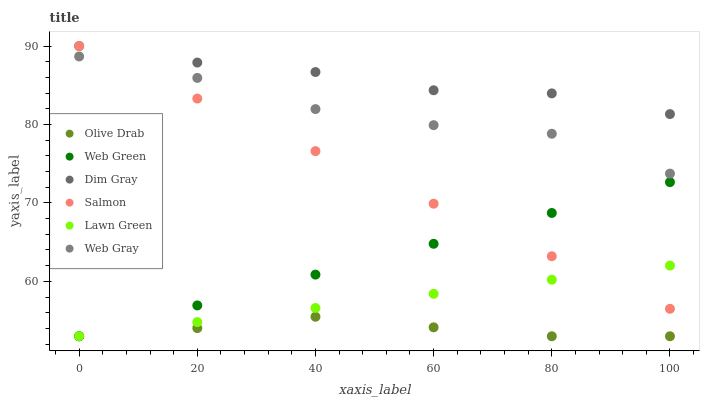Does Olive Drab have the minimum area under the curve?
Answer yes or no. Yes. Does Dim Gray have the maximum area under the curve?
Answer yes or no. Yes. Does Web Gray have the minimum area under the curve?
Answer yes or no. No. Does Web Gray have the maximum area under the curve?
Answer yes or no. No. Is Web Green the smoothest?
Answer yes or no. Yes. Is Web Gray the roughest?
Answer yes or no. Yes. Is Salmon the smoothest?
Answer yes or no. No. Is Salmon the roughest?
Answer yes or no. No. Does Lawn Green have the lowest value?
Answer yes or no. Yes. Does Web Gray have the lowest value?
Answer yes or no. No. Does Salmon have the highest value?
Answer yes or no. Yes. Does Web Gray have the highest value?
Answer yes or no. No. Is Lawn Green less than Dim Gray?
Answer yes or no. Yes. Is Salmon greater than Olive Drab?
Answer yes or no. Yes. Does Olive Drab intersect Web Green?
Answer yes or no. Yes. Is Olive Drab less than Web Green?
Answer yes or no. No. Is Olive Drab greater than Web Green?
Answer yes or no. No. Does Lawn Green intersect Dim Gray?
Answer yes or no. No. 